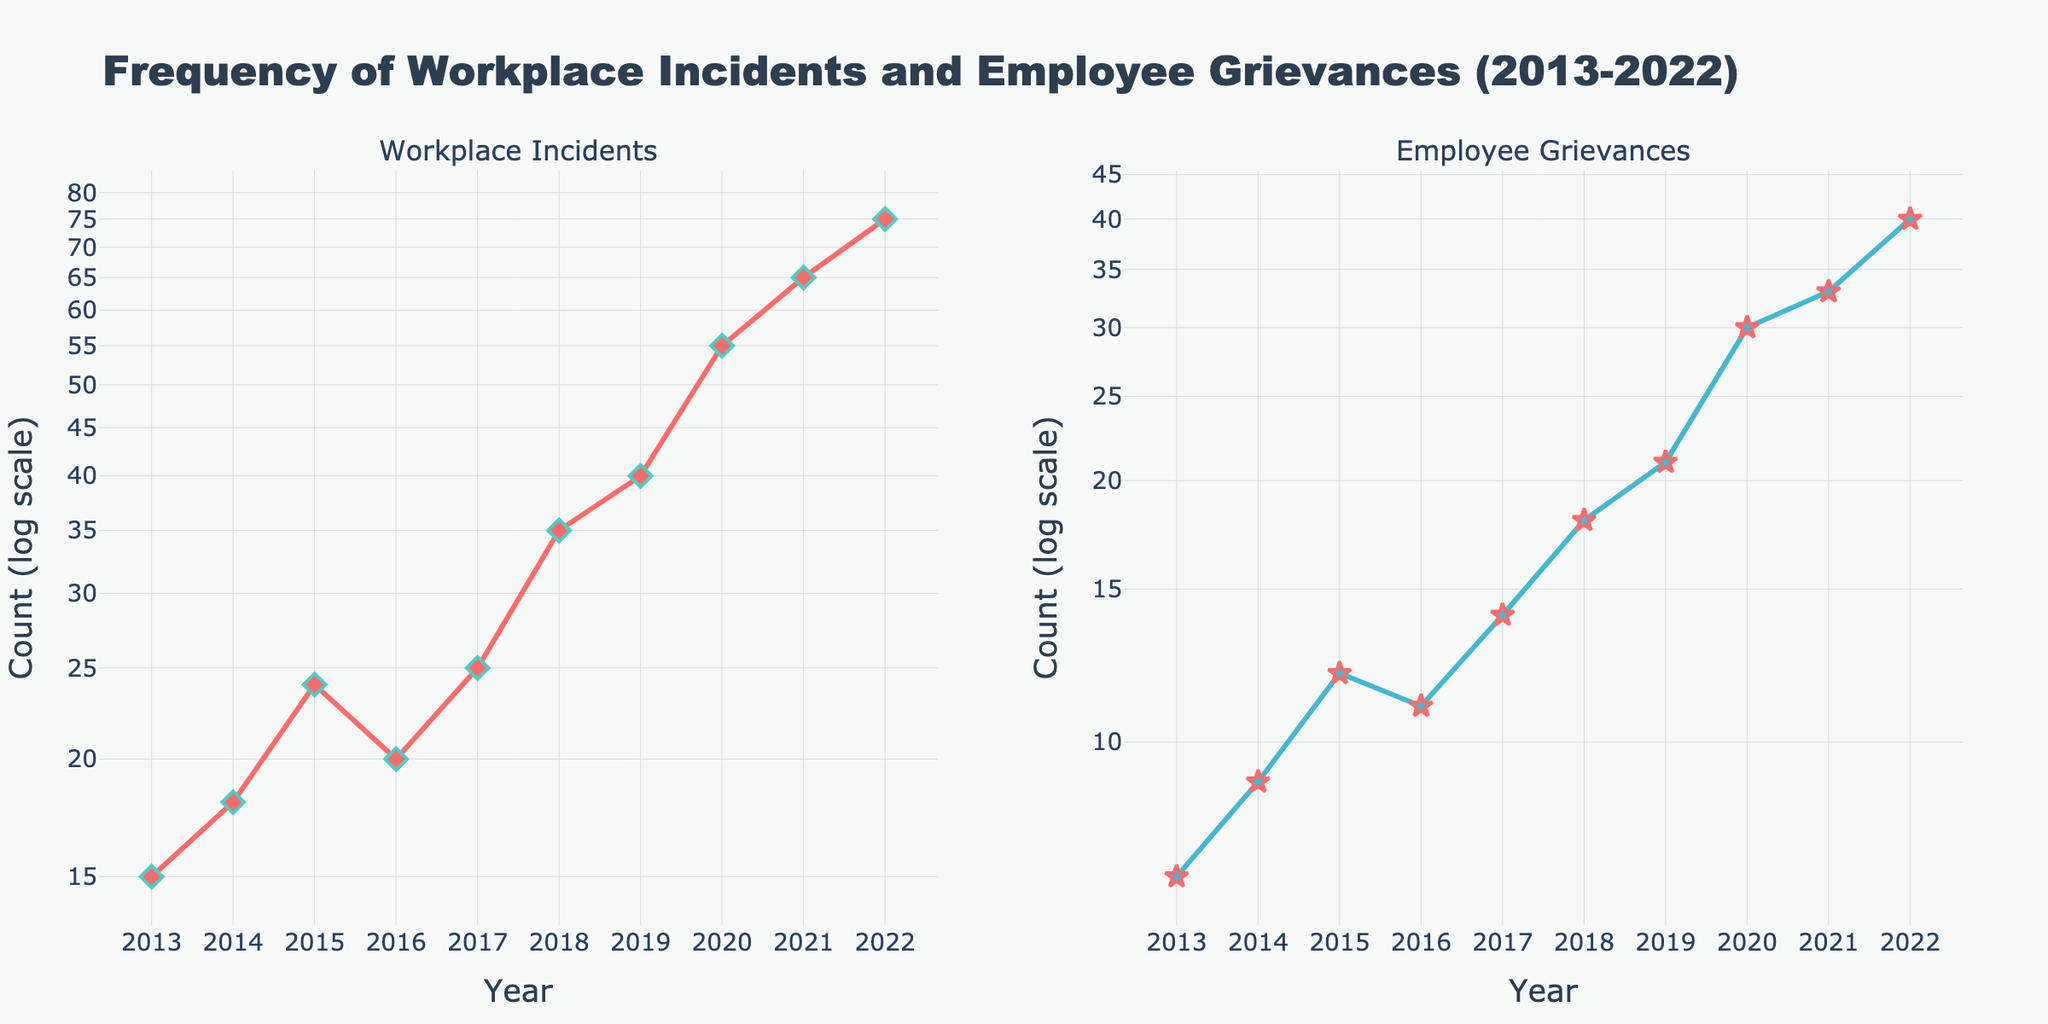What is the trend in the number of workplace incidents from 2013 to 2022? The number of workplace incidents shows a general increasing trend. Starting from 15 incidents in 2013, it gradually increases each year and reaches 75 in 2022.
Answer: Increasing trend How do the numbers of employee grievances compare between 2013 and 2022? In 2013, there were 7 employee grievances reported. By 2022, this number increased to 40, indicating a significant rise over the decade.
Answer: Increased from 7 to 40 What's the range of workplace incidents reported from 2013 to 2022? The range is calculated by subtracting the smallest value from the largest value: 75 (2022) - 15 (2013) = 60.
Answer: 60 How does the rate of change in workplace incidents compare to employee grievances over the decade? Both categories show an increasing trend, but the rate of increase in workplace incidents is higher. Workplace incidents increased by 60 (75-15) while employee grievances increased by 33 (40-7).
Answer: Rate of change is higher for workplace incidents Which year had the highest number of employee grievances reported? The highest number of employee grievances reported is in 2022, with 40 grievances.
Answer: 2022 What relationship do you observe between workplace incidents and employee grievances over the years? Both metrics show a positive correlation, implying that as the number of workplace incidents increases, the number of employee grievances also tends to rise.
Answer: Positive correlation Considering the log scale on the y-axis, what is the approximate value of workplace incidents in 2018 compared to employee grievances in the same year? In 2018, workplace incidents are approximately 35, while employee grievances are approximately 18. Given the log scale, workplace incidents are about twice as much as employee grievances.
Answer: Approximately twice as much Why might the log scale be useful for this data visualization? The log scale is helpful because it clearly shows the proportional change and growth trends over time, which might be less apparent on a linear scale, especially given the wide range of values.
Answer: Shows proportional change and trends clearly 